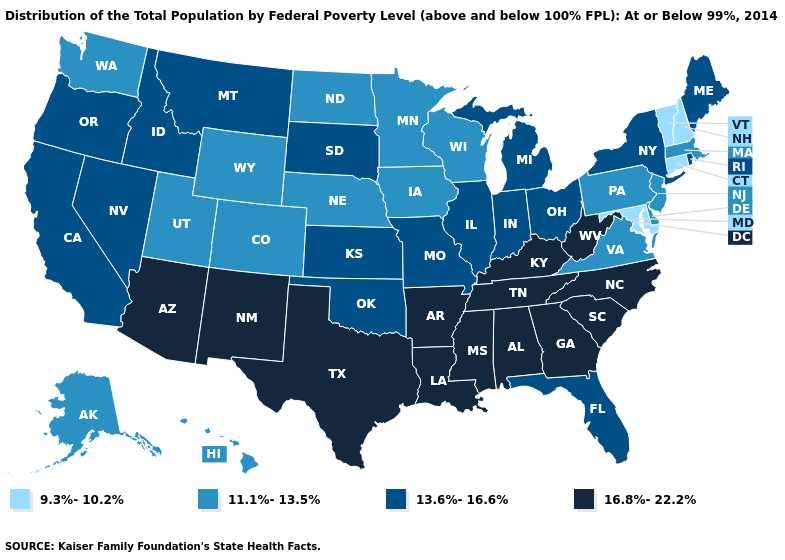What is the value of Michigan?
Concise answer only. 13.6%-16.6%. Name the states that have a value in the range 9.3%-10.2%?
Quick response, please. Connecticut, Maryland, New Hampshire, Vermont. Name the states that have a value in the range 13.6%-16.6%?
Quick response, please. California, Florida, Idaho, Illinois, Indiana, Kansas, Maine, Michigan, Missouri, Montana, Nevada, New York, Ohio, Oklahoma, Oregon, Rhode Island, South Dakota. Name the states that have a value in the range 16.8%-22.2%?
Short answer required. Alabama, Arizona, Arkansas, Georgia, Kentucky, Louisiana, Mississippi, New Mexico, North Carolina, South Carolina, Tennessee, Texas, West Virginia. Among the states that border Nebraska , which have the highest value?
Be succinct. Kansas, Missouri, South Dakota. Does Tennessee have a higher value than Arizona?
Answer briefly. No. Does the first symbol in the legend represent the smallest category?
Give a very brief answer. Yes. Does Georgia have a higher value than New Mexico?
Short answer required. No. Which states have the lowest value in the South?
Give a very brief answer. Maryland. Among the states that border Wyoming , does Idaho have the highest value?
Short answer required. Yes. What is the lowest value in the Northeast?
Be succinct. 9.3%-10.2%. Is the legend a continuous bar?
Answer briefly. No. What is the value of Kentucky?
Be succinct. 16.8%-22.2%. Name the states that have a value in the range 9.3%-10.2%?
Answer briefly. Connecticut, Maryland, New Hampshire, Vermont. 